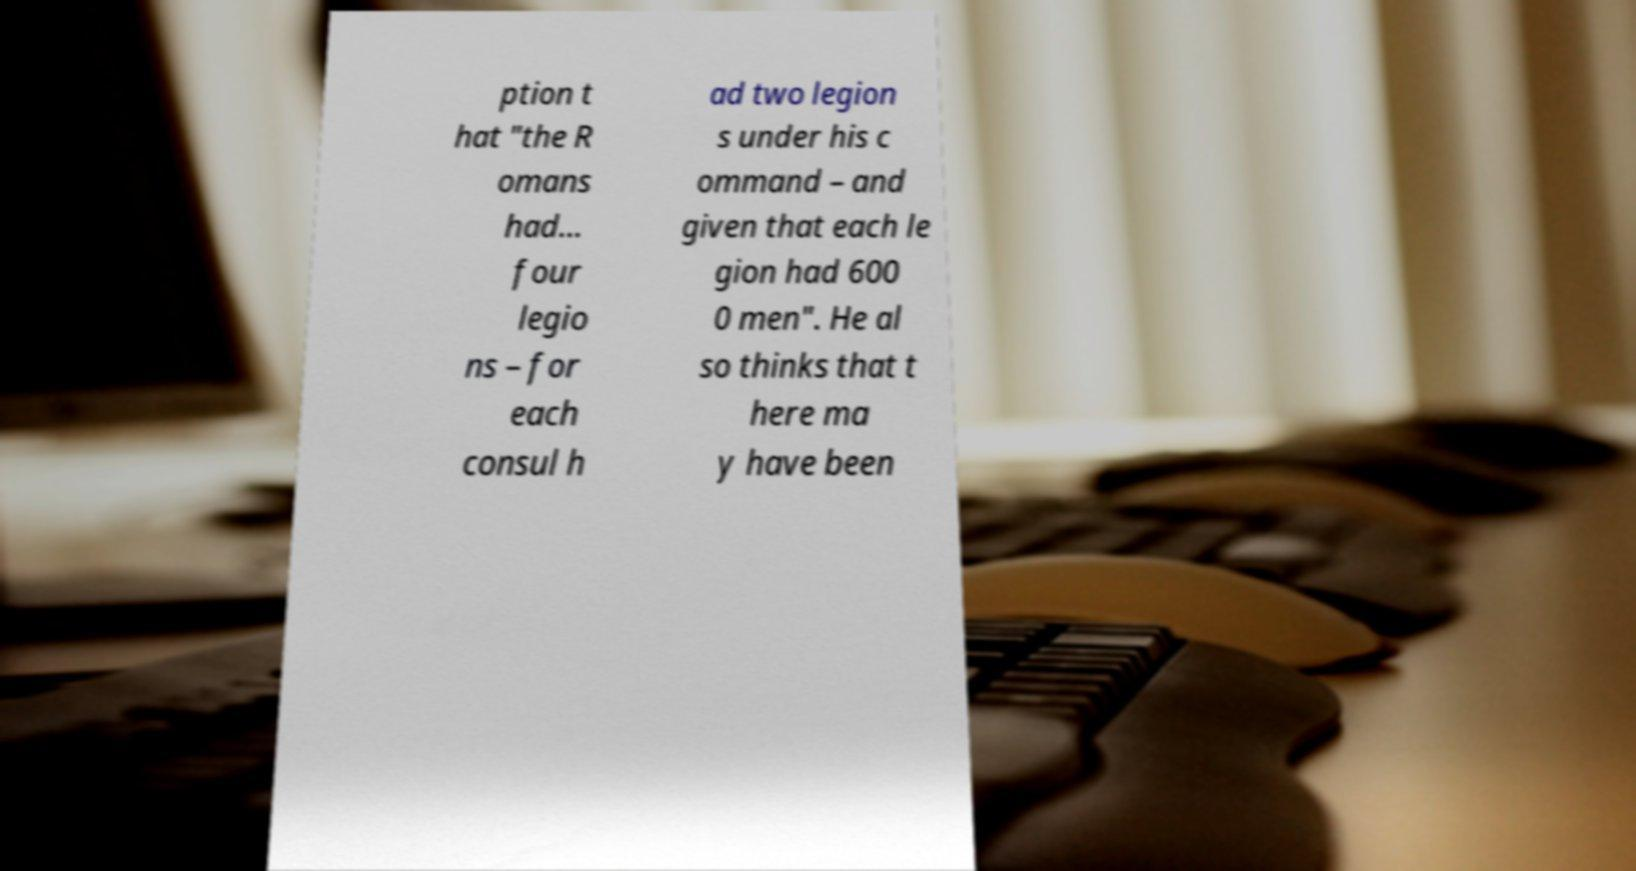Could you assist in decoding the text presented in this image and type it out clearly? ption t hat "the R omans had... four legio ns – for each consul h ad two legion s under his c ommand – and given that each le gion had 600 0 men". He al so thinks that t here ma y have been 